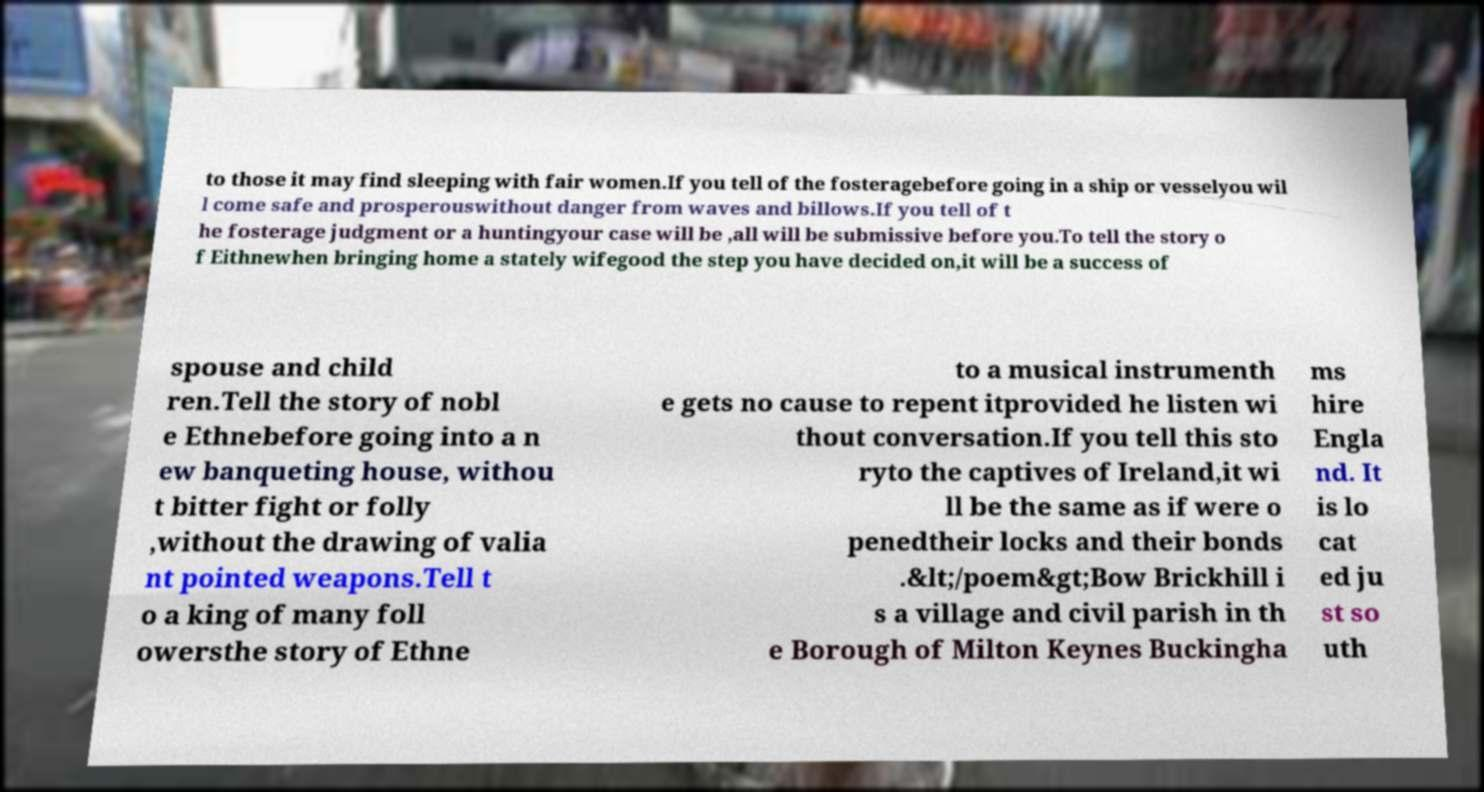I need the written content from this picture converted into text. Can you do that? to those it may find sleeping with fair women.If you tell of the fosteragebefore going in a ship or vesselyou wil l come safe and prosperouswithout danger from waves and billows.If you tell of t he fosterage judgment or a huntingyour case will be ,all will be submissive before you.To tell the story o f Eithnewhen bringing home a stately wifegood the step you have decided on,it will be a success of spouse and child ren.Tell the story of nobl e Ethnebefore going into a n ew banqueting house, withou t bitter fight or folly ,without the drawing of valia nt pointed weapons.Tell t o a king of many foll owersthe story of Ethne to a musical instrumenth e gets no cause to repent itprovided he listen wi thout conversation.If you tell this sto ryto the captives of Ireland,it wi ll be the same as if were o penedtheir locks and their bonds .&lt;/poem&gt;Bow Brickhill i s a village and civil parish in th e Borough of Milton Keynes Buckingha ms hire Engla nd. It is lo cat ed ju st so uth 